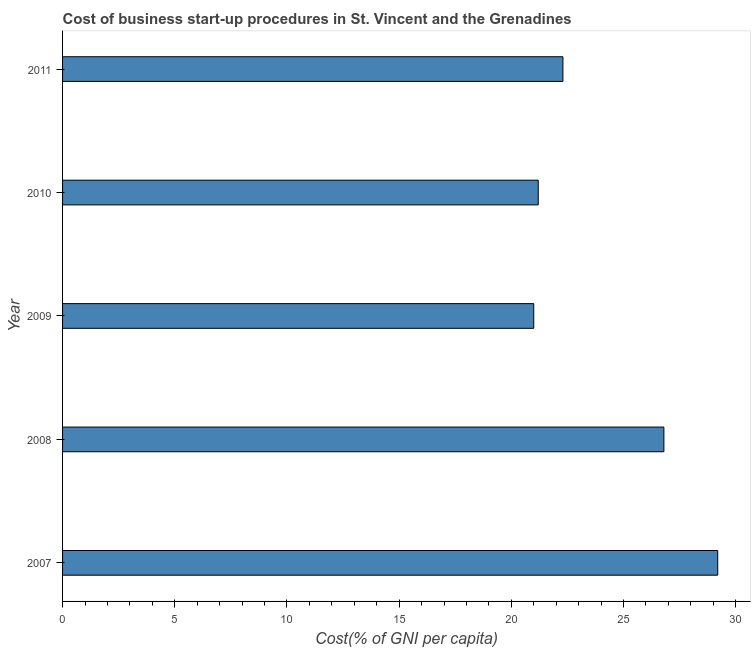Does the graph contain any zero values?
Make the answer very short. No. What is the title of the graph?
Offer a very short reply. Cost of business start-up procedures in St. Vincent and the Grenadines. What is the label or title of the X-axis?
Offer a terse response. Cost(% of GNI per capita). What is the label or title of the Y-axis?
Provide a short and direct response. Year. What is the cost of business startup procedures in 2008?
Offer a terse response. 26.8. Across all years, what is the maximum cost of business startup procedures?
Keep it short and to the point. 29.2. Across all years, what is the minimum cost of business startup procedures?
Ensure brevity in your answer.  21. What is the sum of the cost of business startup procedures?
Your response must be concise. 120.5. What is the average cost of business startup procedures per year?
Your answer should be compact. 24.1. What is the median cost of business startup procedures?
Offer a terse response. 22.3. What is the ratio of the cost of business startup procedures in 2007 to that in 2011?
Your answer should be compact. 1.31. Is the difference between the cost of business startup procedures in 2008 and 2009 greater than the difference between any two years?
Your response must be concise. No. How many bars are there?
Offer a very short reply. 5. How many years are there in the graph?
Provide a succinct answer. 5. Are the values on the major ticks of X-axis written in scientific E-notation?
Offer a very short reply. No. What is the Cost(% of GNI per capita) in 2007?
Provide a succinct answer. 29.2. What is the Cost(% of GNI per capita) of 2008?
Offer a very short reply. 26.8. What is the Cost(% of GNI per capita) of 2009?
Provide a short and direct response. 21. What is the Cost(% of GNI per capita) in 2010?
Make the answer very short. 21.2. What is the Cost(% of GNI per capita) in 2011?
Make the answer very short. 22.3. What is the difference between the Cost(% of GNI per capita) in 2007 and 2011?
Provide a succinct answer. 6.9. What is the difference between the Cost(% of GNI per capita) in 2008 and 2010?
Ensure brevity in your answer.  5.6. What is the difference between the Cost(% of GNI per capita) in 2009 and 2010?
Offer a terse response. -0.2. What is the difference between the Cost(% of GNI per capita) in 2009 and 2011?
Make the answer very short. -1.3. What is the difference between the Cost(% of GNI per capita) in 2010 and 2011?
Make the answer very short. -1.1. What is the ratio of the Cost(% of GNI per capita) in 2007 to that in 2008?
Your response must be concise. 1.09. What is the ratio of the Cost(% of GNI per capita) in 2007 to that in 2009?
Your answer should be very brief. 1.39. What is the ratio of the Cost(% of GNI per capita) in 2007 to that in 2010?
Ensure brevity in your answer.  1.38. What is the ratio of the Cost(% of GNI per capita) in 2007 to that in 2011?
Keep it short and to the point. 1.31. What is the ratio of the Cost(% of GNI per capita) in 2008 to that in 2009?
Provide a short and direct response. 1.28. What is the ratio of the Cost(% of GNI per capita) in 2008 to that in 2010?
Keep it short and to the point. 1.26. What is the ratio of the Cost(% of GNI per capita) in 2008 to that in 2011?
Ensure brevity in your answer.  1.2. What is the ratio of the Cost(% of GNI per capita) in 2009 to that in 2010?
Keep it short and to the point. 0.99. What is the ratio of the Cost(% of GNI per capita) in 2009 to that in 2011?
Keep it short and to the point. 0.94. What is the ratio of the Cost(% of GNI per capita) in 2010 to that in 2011?
Your answer should be very brief. 0.95. 